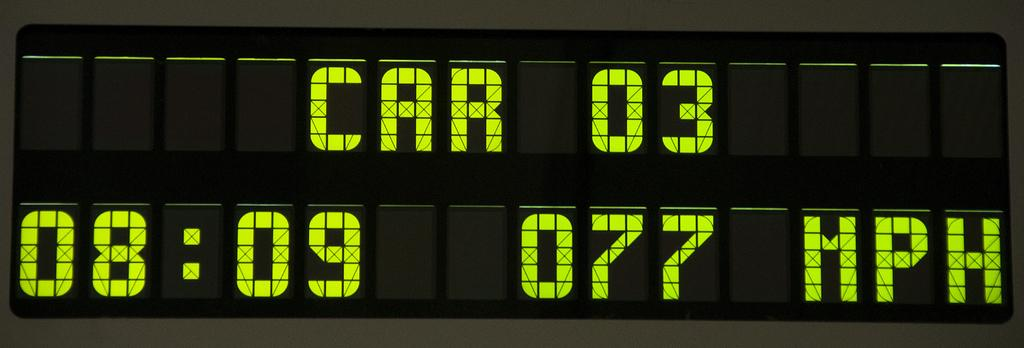<image>
Share a concise interpretation of the image provided. Black digital electronic display with green font reading CAR 03 